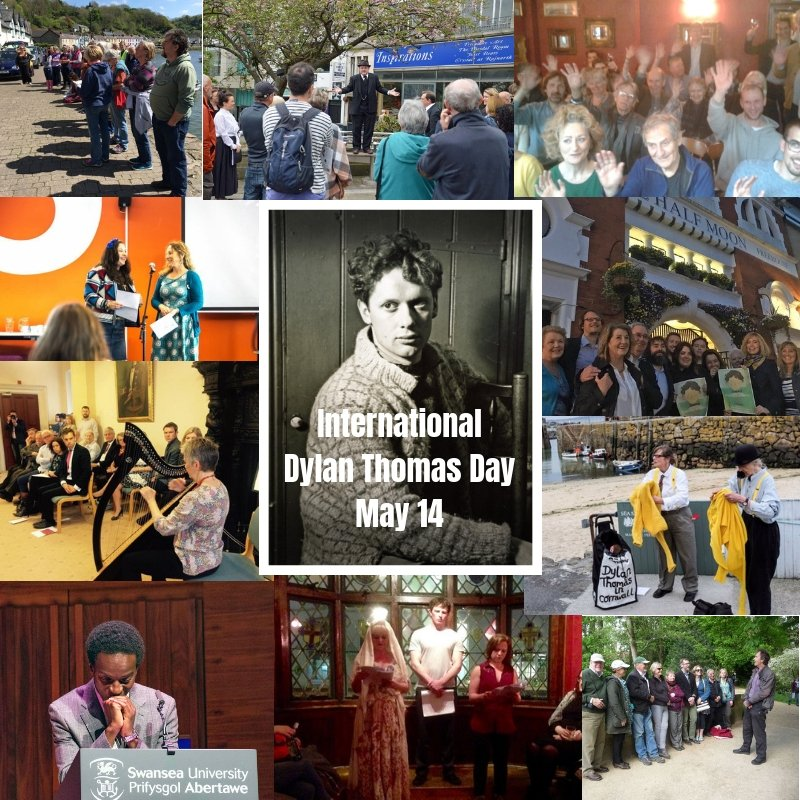What might be the significance of the blue plaque in the top center photograph, and how does it relate to the theme of the collage? The blue plaque in the top center photograph likely signifies a location of historical importance associated with Dylan Thomas, such as his former home, a place where he wrote or performed, or a location that played a significant role in his life. Blue plaques are commonly used in the UK to commemorate notable individuals and their connections to specific sites. Given the theme of the collage, which is dedicated to International Dylan Thomas Day, the plaque's relevance is underscored by the surrounding images of activities celebrating his literary contributions. The presence of people gathered around the plaque suggests it is a focal point for remembrance and celebration during events held on Dylan Thomas Day. 